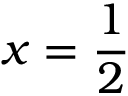Convert formula to latex. <formula><loc_0><loc_0><loc_500><loc_500>x = { \frac { 1 } { 2 } }</formula> 